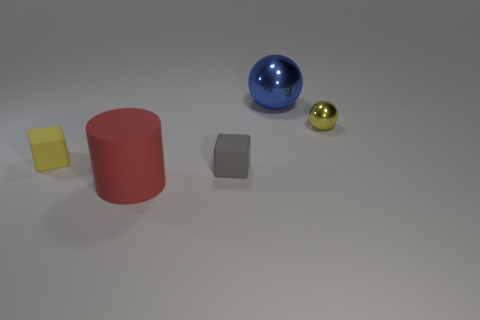How many objects are either yellow metallic cylinders or rubber objects?
Your answer should be compact. 3. Does the ball that is to the right of the blue shiny thing have the same color as the large object that is in front of the tiny yellow rubber object?
Give a very brief answer. No. What shape is the yellow matte thing that is the same size as the gray rubber object?
Provide a succinct answer. Cube. How many things are either large red cylinders that are in front of the yellow cube or balls to the right of the large blue sphere?
Keep it short and to the point. 2. Is the number of large blue balls less than the number of cyan shiny cubes?
Ensure brevity in your answer.  No. There is another yellow object that is the same size as the yellow matte object; what is its material?
Offer a very short reply. Metal. Do the yellow thing that is right of the tiny yellow rubber thing and the rubber block that is left of the gray rubber thing have the same size?
Offer a terse response. Yes. Are there any other gray objects that have the same material as the gray thing?
Keep it short and to the point. No. What number of things are either rubber cubes on the left side of the big red cylinder or blue blocks?
Your response must be concise. 1. Are the large object that is in front of the small metal object and the big blue thing made of the same material?
Offer a terse response. No. 